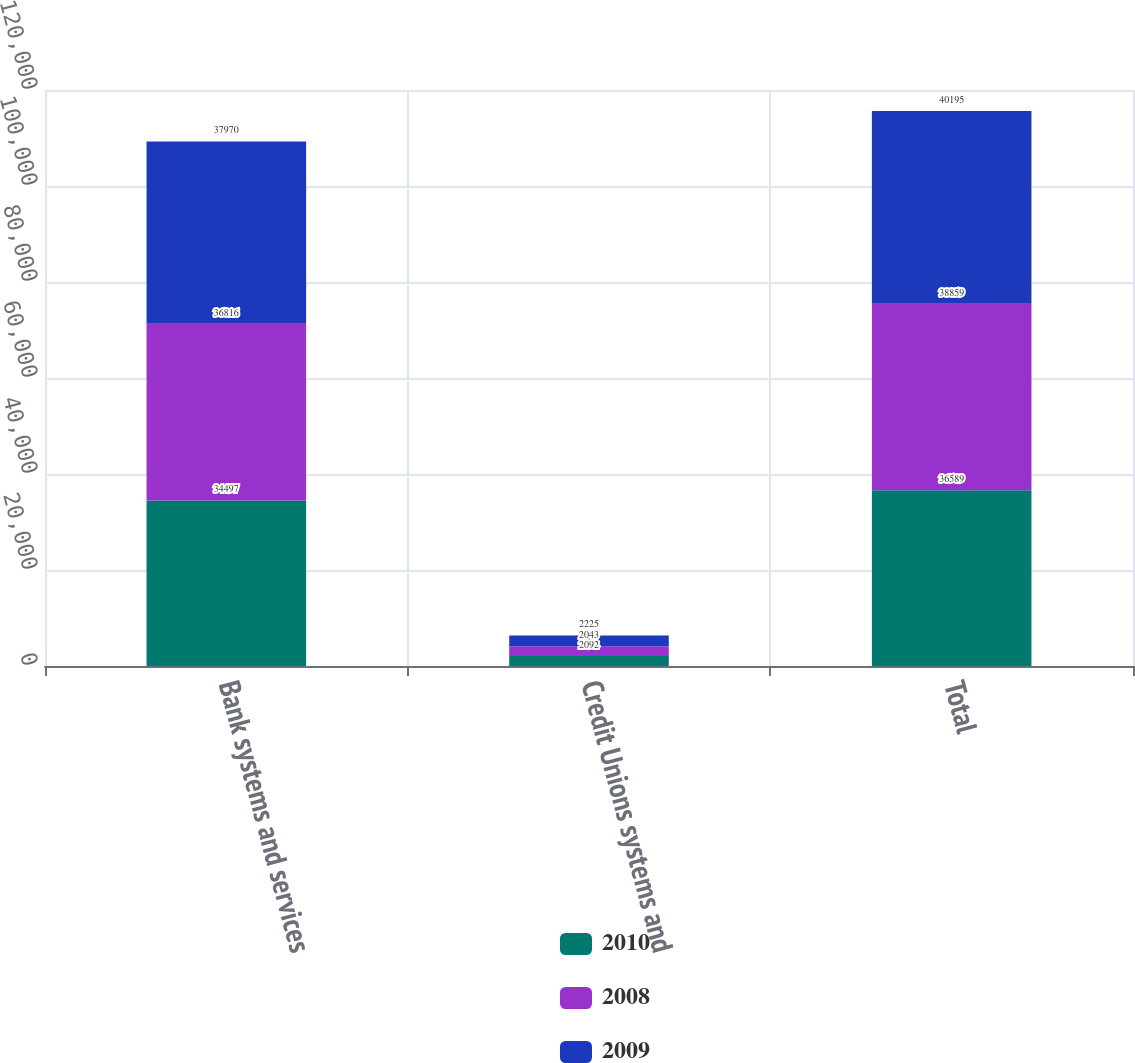Convert chart to OTSL. <chart><loc_0><loc_0><loc_500><loc_500><stacked_bar_chart><ecel><fcel>Bank systems and services<fcel>Credit Unions systems and<fcel>Total<nl><fcel>2010<fcel>34497<fcel>2092<fcel>36589<nl><fcel>2008<fcel>36816<fcel>2043<fcel>38859<nl><fcel>2009<fcel>37970<fcel>2225<fcel>40195<nl></chart> 